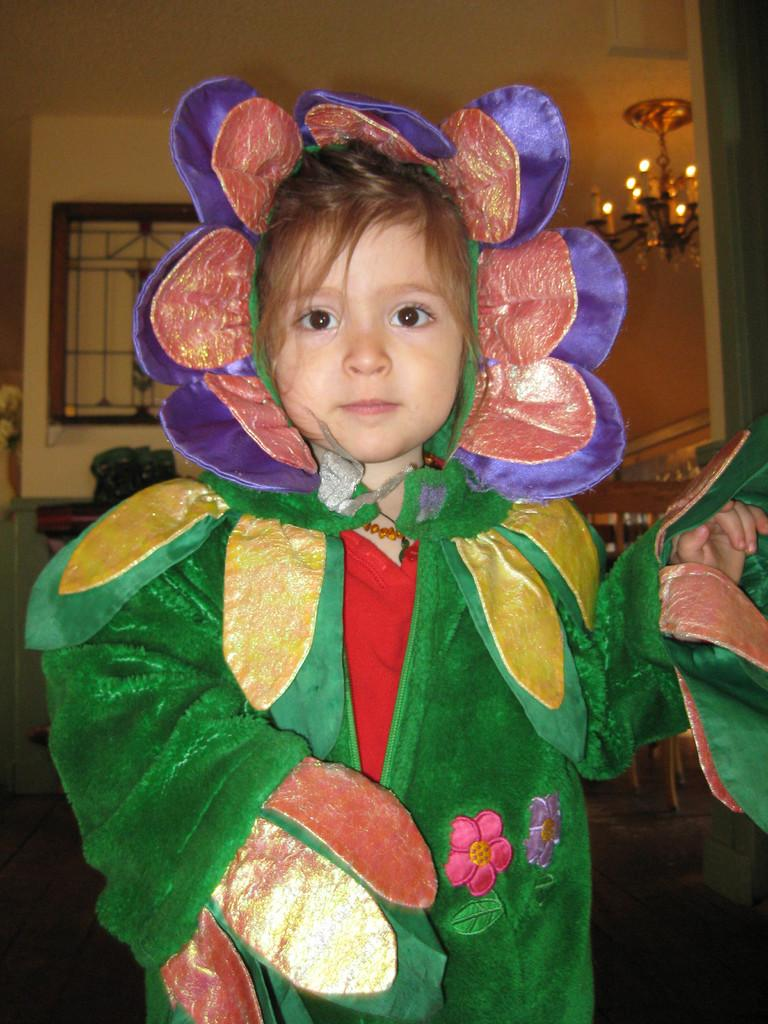What is the main subject of the image? There is a child in the image. What is the child wearing? The child is wearing a green costume. What is the child's posture in the image? The child is standing. What can be seen in the background of the image? There is a chandelier and a wall in the background of the image. What advice does the child give to the flower in the image? There is no flower present in the image, so the child cannot give advice to a flower. 